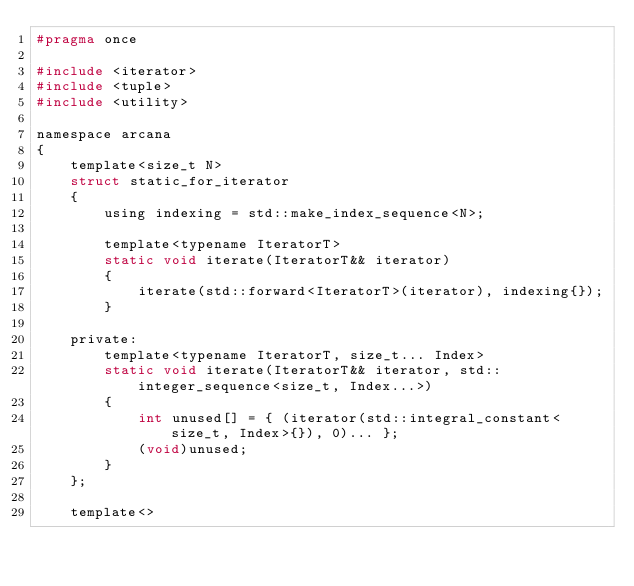Convert code to text. <code><loc_0><loc_0><loc_500><loc_500><_C_>#pragma once

#include <iterator>
#include <tuple>
#include <utility>

namespace arcana
{
    template<size_t N>
    struct static_for_iterator
    {
        using indexing = std::make_index_sequence<N>;

        template<typename IteratorT>
        static void iterate(IteratorT&& iterator)
        {
            iterate(std::forward<IteratorT>(iterator), indexing{});
        }

    private:
        template<typename IteratorT, size_t... Index>
        static void iterate(IteratorT&& iterator, std::integer_sequence<size_t, Index...>)
        {
            int unused[] = { (iterator(std::integral_constant<size_t, Index>{}), 0)... };
            (void)unused;
        }
    };

    template<></code> 